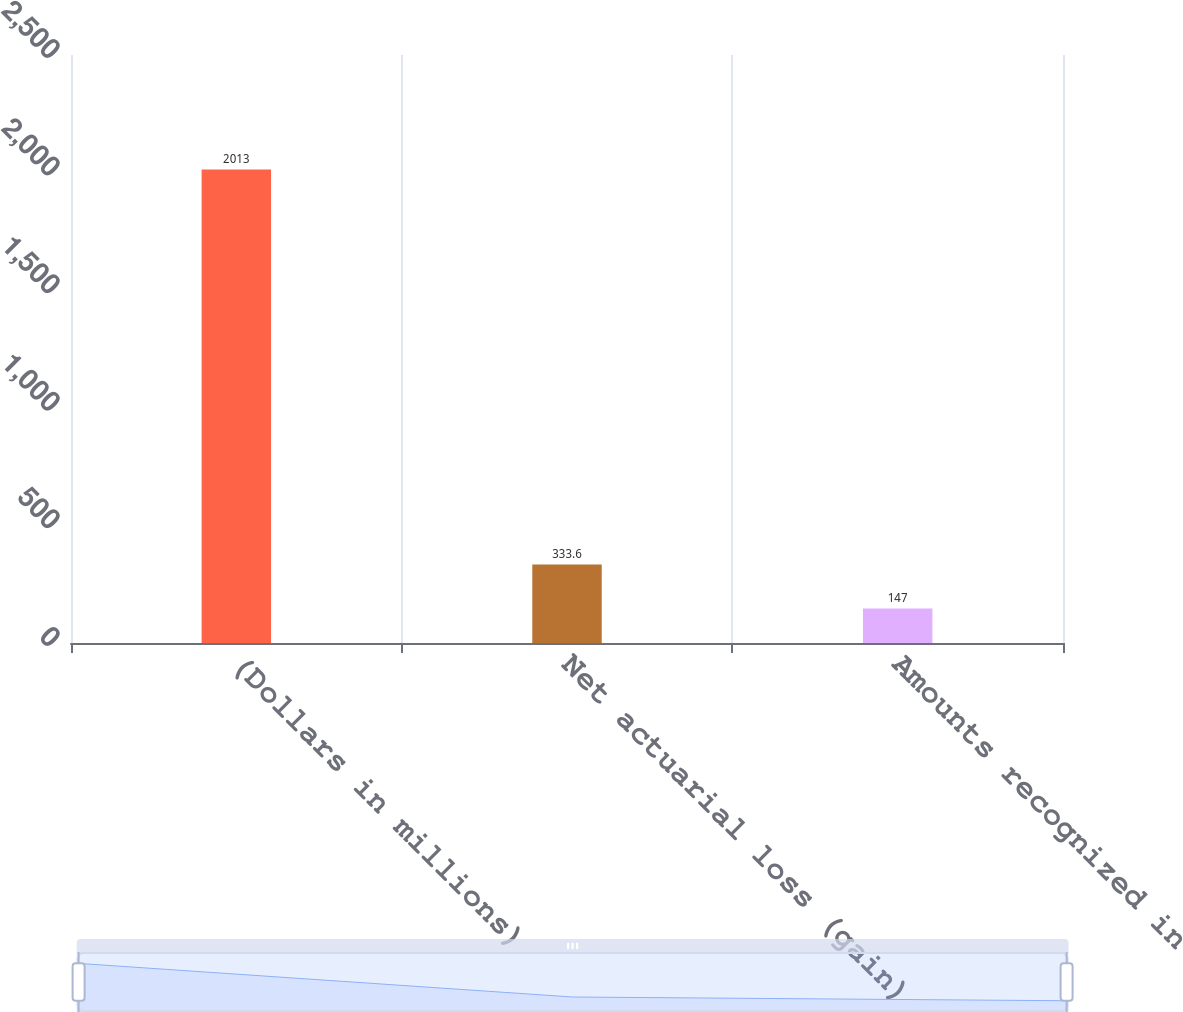Convert chart. <chart><loc_0><loc_0><loc_500><loc_500><bar_chart><fcel>(Dollars in millions)<fcel>Net actuarial loss (gain)<fcel>Amounts recognized in<nl><fcel>2013<fcel>333.6<fcel>147<nl></chart> 